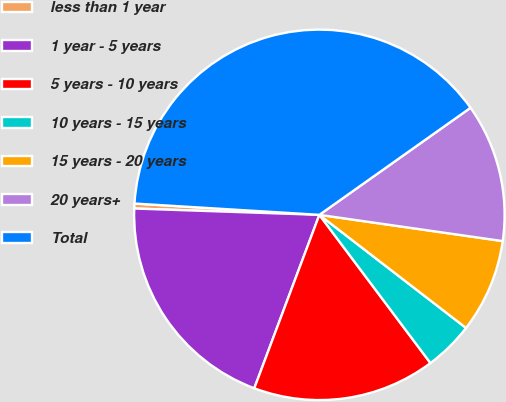<chart> <loc_0><loc_0><loc_500><loc_500><pie_chart><fcel>less than 1 year<fcel>1 year - 5 years<fcel>5 years - 10 years<fcel>10 years - 15 years<fcel>15 years - 20 years<fcel>20 years+<fcel>Total<nl><fcel>0.43%<fcel>19.83%<fcel>15.95%<fcel>4.31%<fcel>8.19%<fcel>12.07%<fcel>39.22%<nl></chart> 